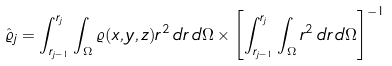<formula> <loc_0><loc_0><loc_500><loc_500>\hat { \varrho } _ { j } = \int _ { r _ { j - 1 } } ^ { r _ { j } } \int _ { \Omega } \varrho ( x , y , z ) r ^ { 2 } \, d r \, d \Omega \times \left [ \int _ { r _ { j - 1 } } ^ { r _ { j } } \int _ { \Omega } r ^ { 2 } \, d r \, d \Omega \right ] ^ { - 1 }</formula> 